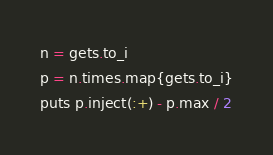Convert code to text. <code><loc_0><loc_0><loc_500><loc_500><_Ruby_>n = gets.to_i
p = n.times.map{gets.to_i}
puts p.inject(:+) - p.max / 2</code> 